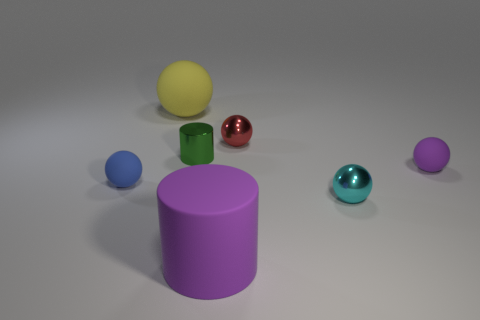Is there any other thing that has the same color as the tiny cylinder?
Provide a succinct answer. No. What number of objects are big matte objects that are behind the large purple rubber cylinder or things that are on the left side of the large yellow sphere?
Give a very brief answer. 2. What is the shape of the tiny metallic thing that is in front of the red shiny ball and right of the tiny green metallic cylinder?
Offer a terse response. Sphere. There is a metal ball in front of the tiny blue matte object; how many blue rubber balls are behind it?
Your answer should be compact. 1. Is there anything else that has the same material as the small blue object?
Provide a succinct answer. Yes. How many objects are large rubber things that are in front of the yellow sphere or gray spheres?
Your answer should be very brief. 1. What is the size of the metal ball that is behind the tiny purple rubber sphere?
Your answer should be compact. Small. What is the material of the red sphere?
Provide a short and direct response. Metal. The metal thing that is on the left side of the purple rubber cylinder to the left of the tiny cyan object is what shape?
Give a very brief answer. Cylinder. How many other objects are the same shape as the big yellow thing?
Your answer should be very brief. 4. 